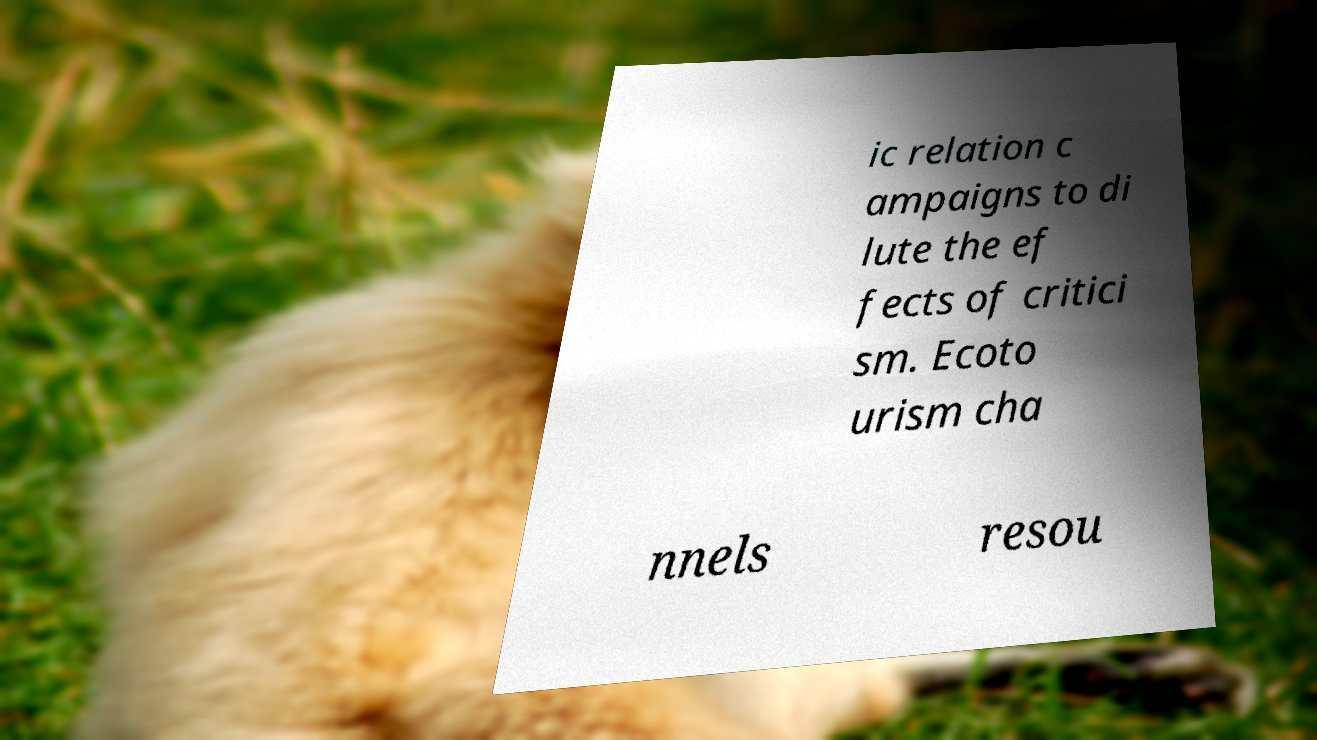Can you read and provide the text displayed in the image?This photo seems to have some interesting text. Can you extract and type it out for me? ic relation c ampaigns to di lute the ef fects of critici sm. Ecoto urism cha nnels resou 